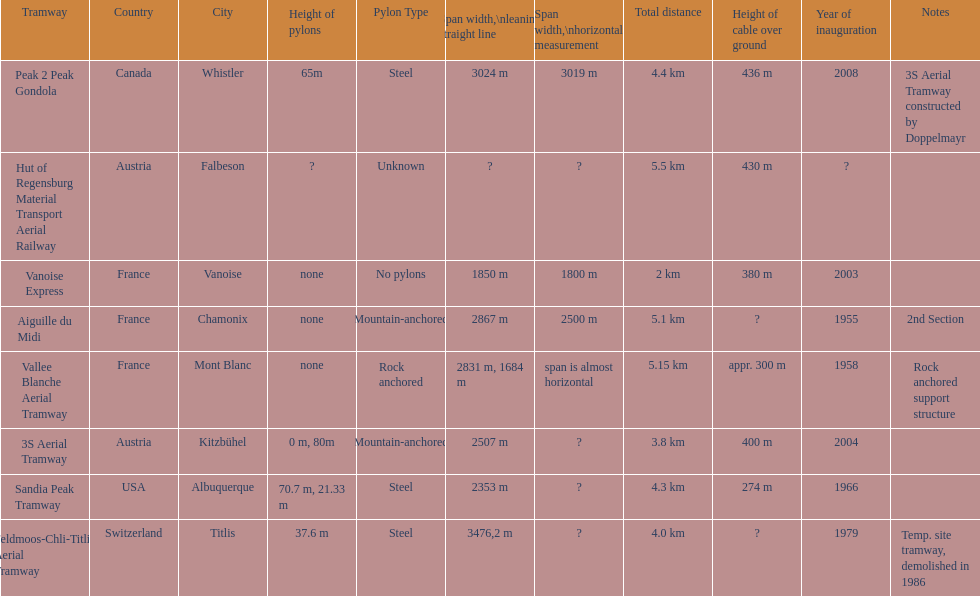At least how many aerial tramways were inaugurated after 1970? 4. 